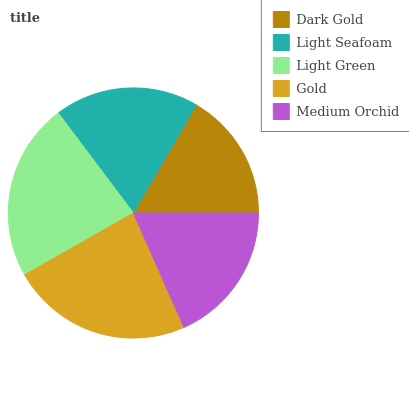Is Dark Gold the minimum?
Answer yes or no. Yes. Is Gold the maximum?
Answer yes or no. Yes. Is Light Seafoam the minimum?
Answer yes or no. No. Is Light Seafoam the maximum?
Answer yes or no. No. Is Light Seafoam greater than Dark Gold?
Answer yes or no. Yes. Is Dark Gold less than Light Seafoam?
Answer yes or no. Yes. Is Dark Gold greater than Light Seafoam?
Answer yes or no. No. Is Light Seafoam less than Dark Gold?
Answer yes or no. No. Is Light Seafoam the high median?
Answer yes or no. Yes. Is Light Seafoam the low median?
Answer yes or no. Yes. Is Medium Orchid the high median?
Answer yes or no. No. Is Gold the low median?
Answer yes or no. No. 